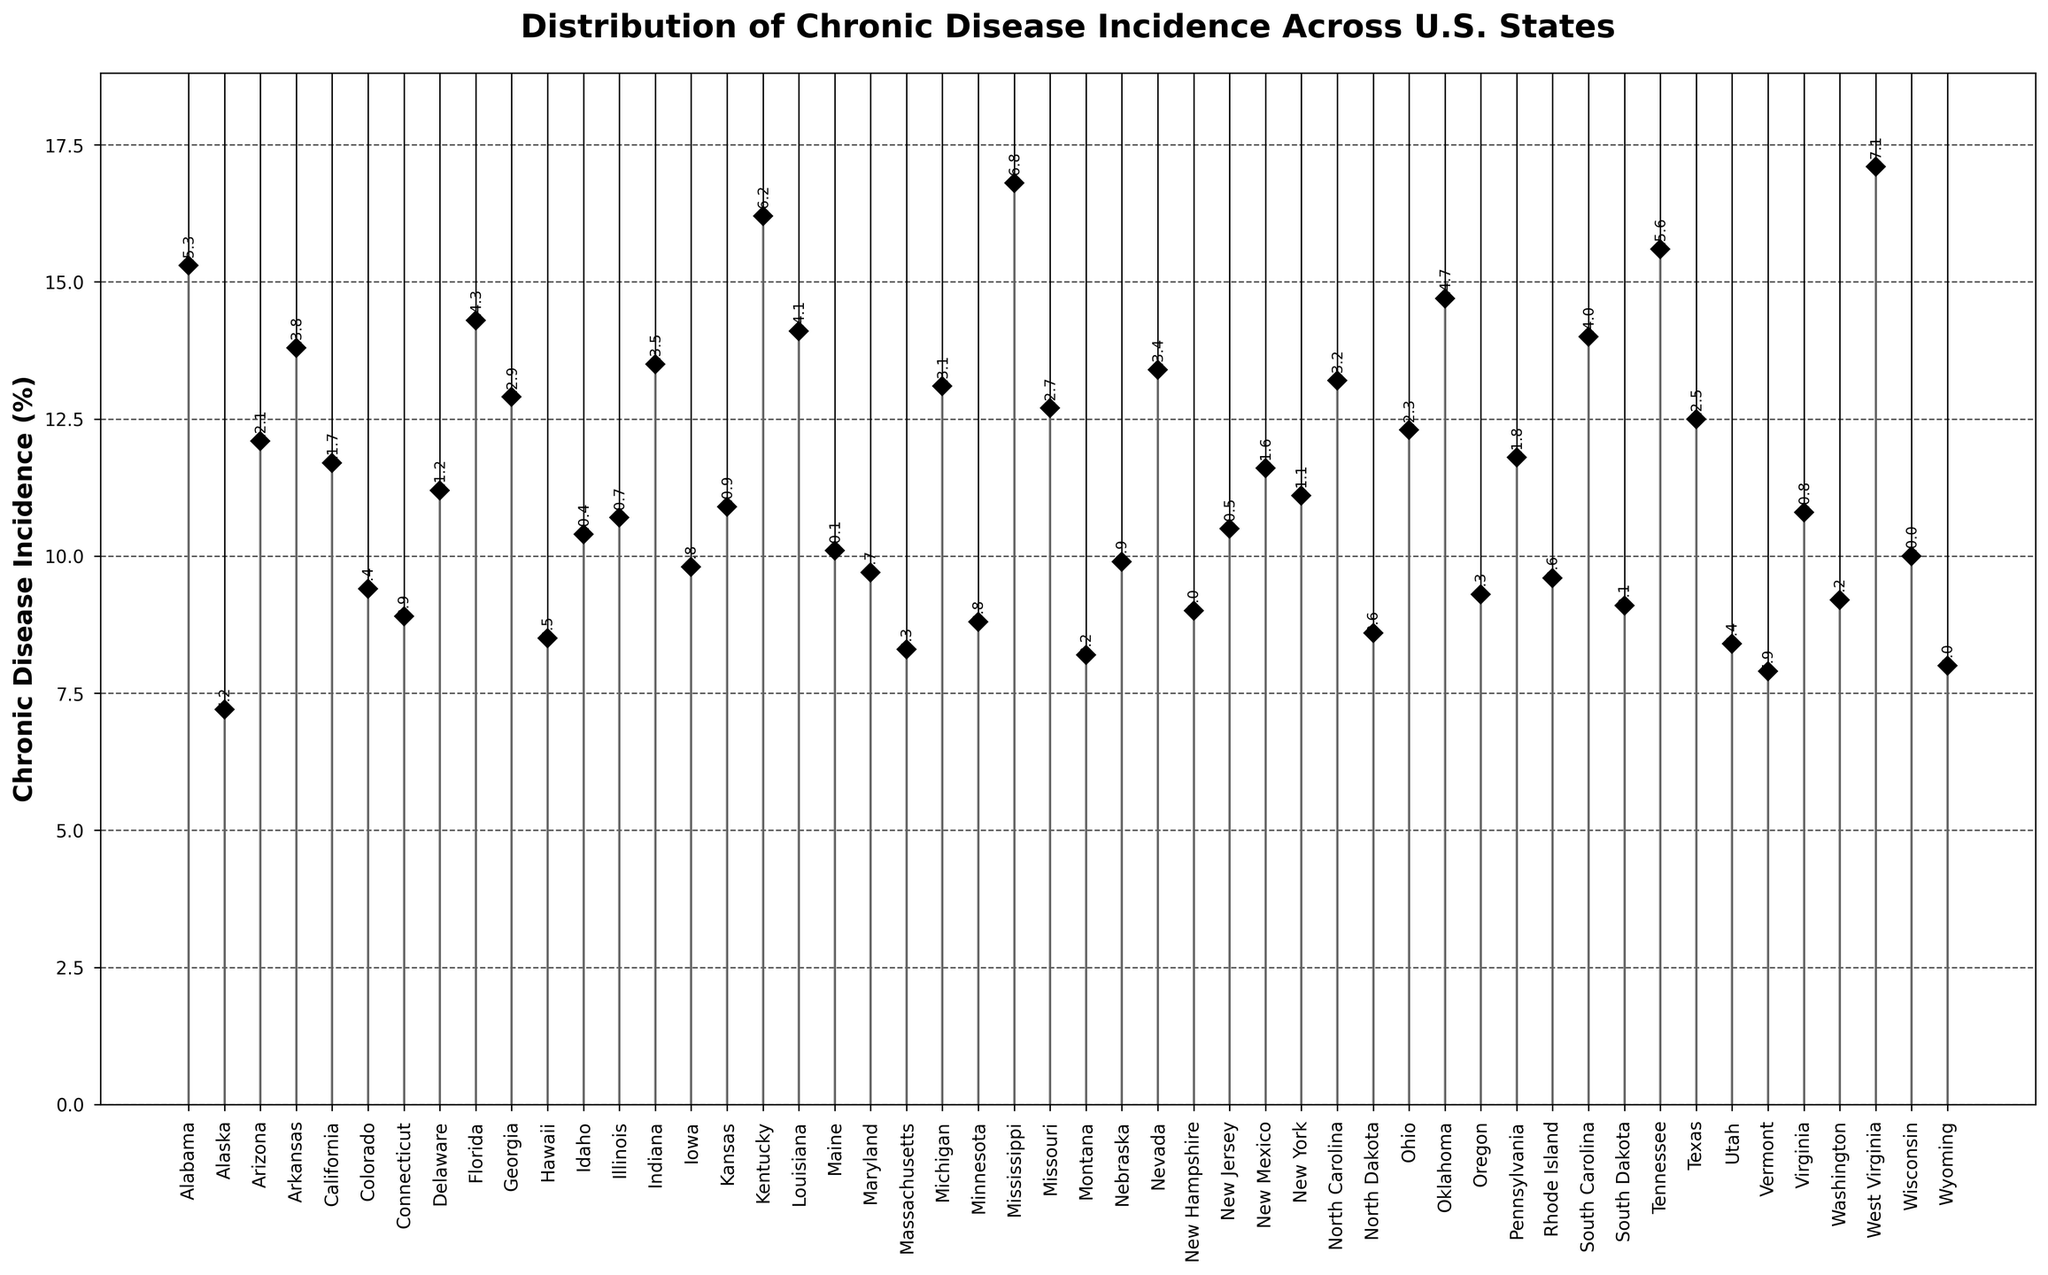What's the title of the plot? The title is usually placed at the top of the plot. In this case, it reads 'Distribution of Chronic Disease Incidence Across U.S. States'.
Answer: Distribution of Chronic Disease Incidence Across U.S. States What is the highest incidence rate of chronic disease among the states? By examining the stem plot, the highest stem marker can be identified. For this plot, West Virginia has the highest incidence rate.
Answer: 17.1% Which state has the lowest incidence rate of chronic disease? The lowest stem marker on the plot represents the state with the lowest incidence rate. Here, it is Alaska.
Answer: 7.2% What is the chronic disease incidence rate in California? Locate the marker corresponding to California on the X-axis and read off the Y-axis value. The plot shows California has an incidence rate of 11.7%.
Answer: 11.7% How many states have an incidence rate higher than 15%? By counting the stems that extend above the 15% mark on the Y-axis, there are four states: Alabama, Kentucky, Mississippi, and West Virginia.
Answer: 4 Compare the chronic disease incidence between Alabama and Alaska. Find Alabama and Alaska on the X-axis and compare their Y-axis values. Alabama has an incidence rate of 15.3%, while Alaska has 7.2%. Alabama's incidence is higher.
Answer: Alabama has a higher incidence rate Which state has an incidence rate closest to 10%? Locate the markers near the 10% line on the Y-axis and identify the state with a value nearest to this line. Wisconsin has an incidence rate of 10.0%.
Answer: Wisconsin What's the range of chronic disease incidence rates among the states? The range is calculated by subtracting the lowest incidence rate from the highest incidence rate. Highest rate: 17.1%, lowest rate: 7.2%, so the range is 17.1 - 7.2 = 9.9%.
Answer: 9.9% What's the average incidence rate of chronic diseases in the states? Sum all the incidence rates and divide by the number of states (50). Total sum: 532.8, number of states: 50, so the average is 532.8 / 50 = 10.656%.
Answer: 10.7% How does the incidence rate in Texas compare to that in Georgia? Find Texas and Georgia on the X-axis and compare their Y-axis values. Texas has an incidence rate of 12.5%, and Georgia has 12.9%. Georgia's rate is slightly higher.
Answer: Georgia is higher 